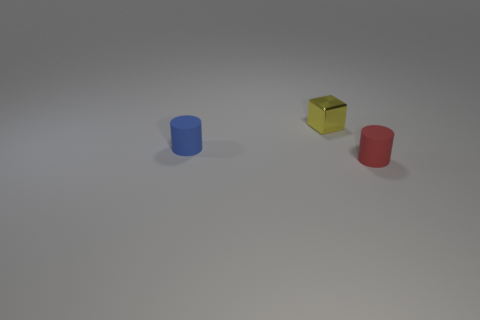Add 1 metal things. How many objects exist? 4 Subtract all cylinders. How many objects are left? 1 Subtract all large yellow cylinders. Subtract all tiny matte things. How many objects are left? 1 Add 1 small matte objects. How many small matte objects are left? 3 Add 1 blue cylinders. How many blue cylinders exist? 2 Subtract all blue cylinders. How many cylinders are left? 1 Subtract 1 red cylinders. How many objects are left? 2 Subtract 1 cylinders. How many cylinders are left? 1 Subtract all yellow cylinders. Subtract all green blocks. How many cylinders are left? 2 Subtract all red blocks. How many brown cylinders are left? 0 